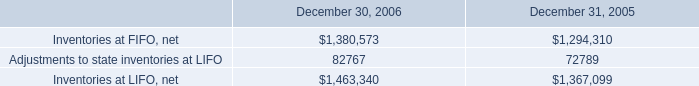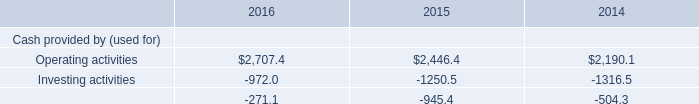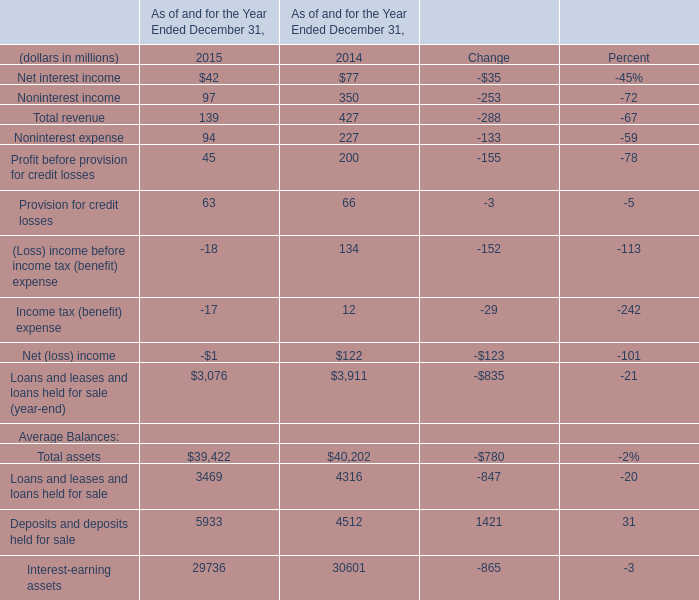What is the average amount of Adjustments to state inventories at LIFO of December 31, 2005, and Operating activities of 2015 ? 
Computations: ((72789.0 + 2446.4) / 2)
Answer: 37617.7. 